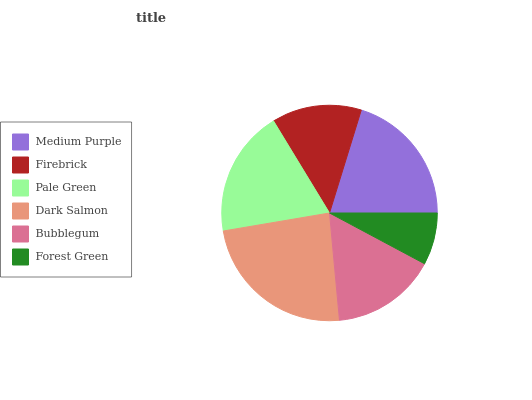Is Forest Green the minimum?
Answer yes or no. Yes. Is Dark Salmon the maximum?
Answer yes or no. Yes. Is Firebrick the minimum?
Answer yes or no. No. Is Firebrick the maximum?
Answer yes or no. No. Is Medium Purple greater than Firebrick?
Answer yes or no. Yes. Is Firebrick less than Medium Purple?
Answer yes or no. Yes. Is Firebrick greater than Medium Purple?
Answer yes or no. No. Is Medium Purple less than Firebrick?
Answer yes or no. No. Is Pale Green the high median?
Answer yes or no. Yes. Is Bubblegum the low median?
Answer yes or no. Yes. Is Forest Green the high median?
Answer yes or no. No. Is Forest Green the low median?
Answer yes or no. No. 